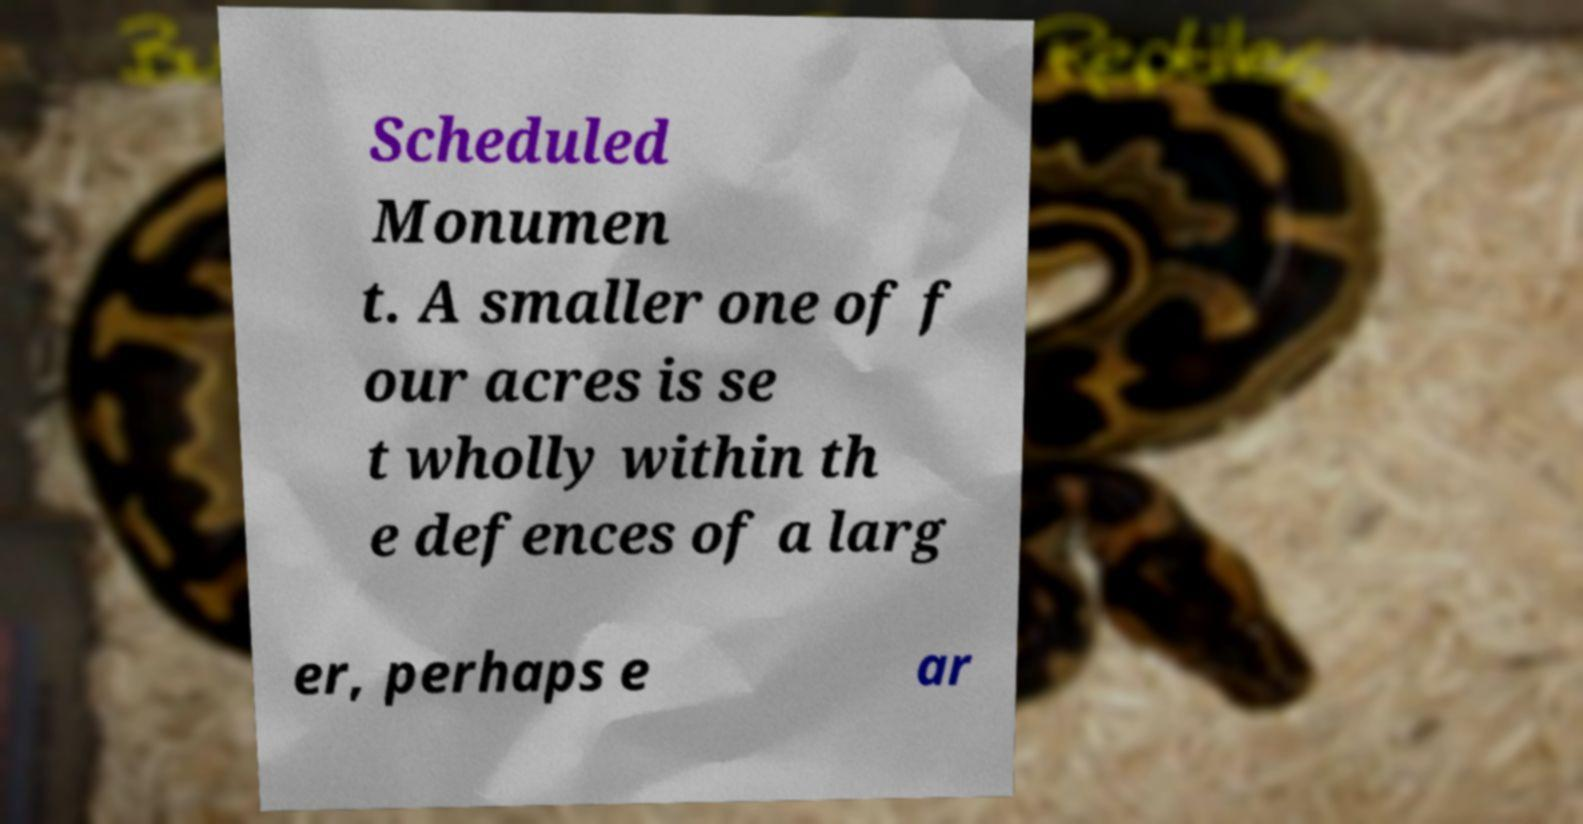What messages or text are displayed in this image? I need them in a readable, typed format. Scheduled Monumen t. A smaller one of f our acres is se t wholly within th e defences of a larg er, perhaps e ar 